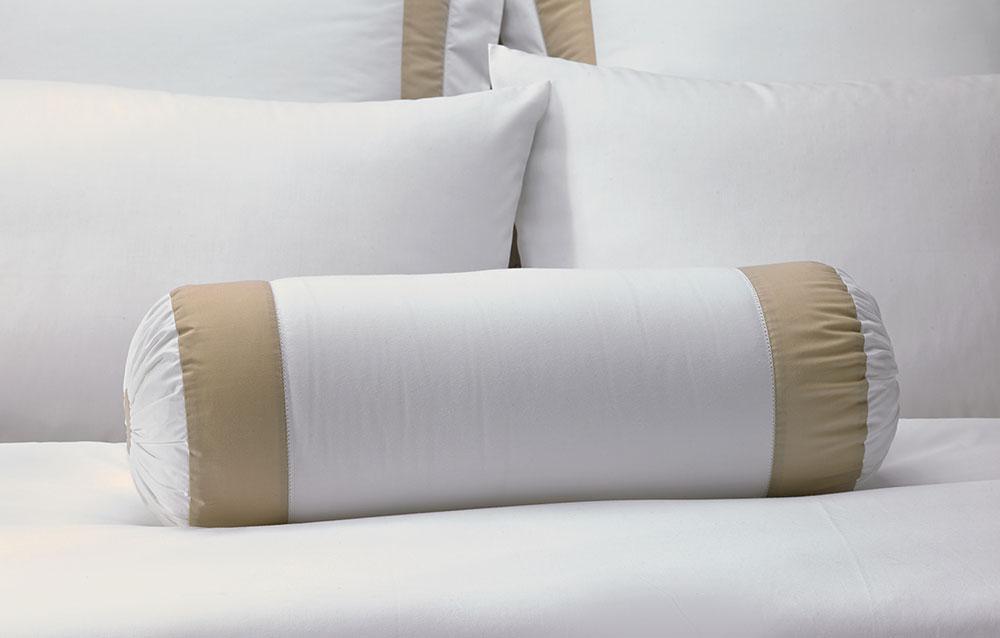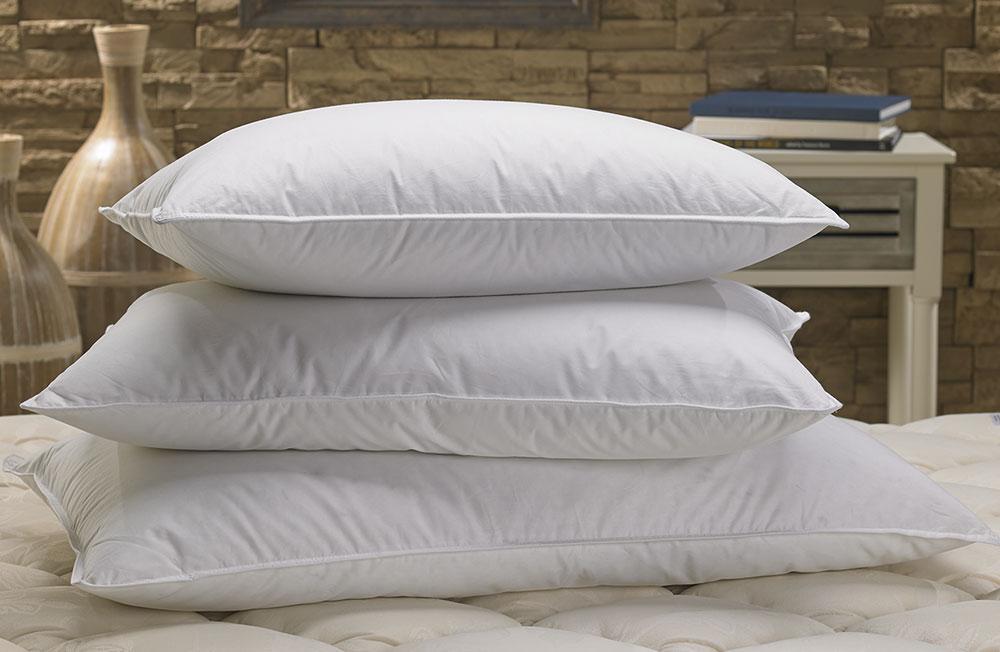The first image is the image on the left, the second image is the image on the right. For the images displayed, is the sentence "In one image a roll pillow with tan stripes is in front of white rectangular upright bed billows." factually correct? Answer yes or no. Yes. The first image is the image on the left, the second image is the image on the right. Assess this claim about the two images: "An image includes a cylindrical pillow with beige bands on each end.". Correct or not? Answer yes or no. Yes. 